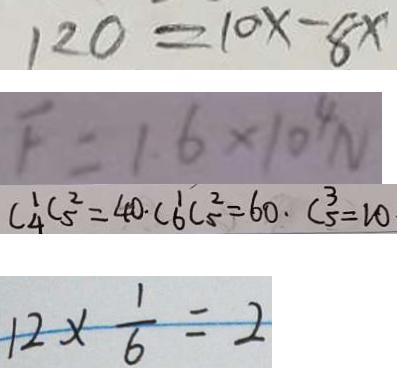<formula> <loc_0><loc_0><loc_500><loc_500>1 2 0 = 1 0 x - 8 x 
 F = 1 . 6 \times 1 0 ^ { 4 } N 
 C _ { 4 } ^ { 1 } C _ { 5 } ^ { 2 } = 4 0 \cdot C _ { 6 } ^ { 1 } C _ { 5 } ^ { 2 } = 6 0 \cdot C _ { 5 } ^ { 3 } = 1 0 
 1 2 \times \frac { 1 } { 6 } = 2</formula> 